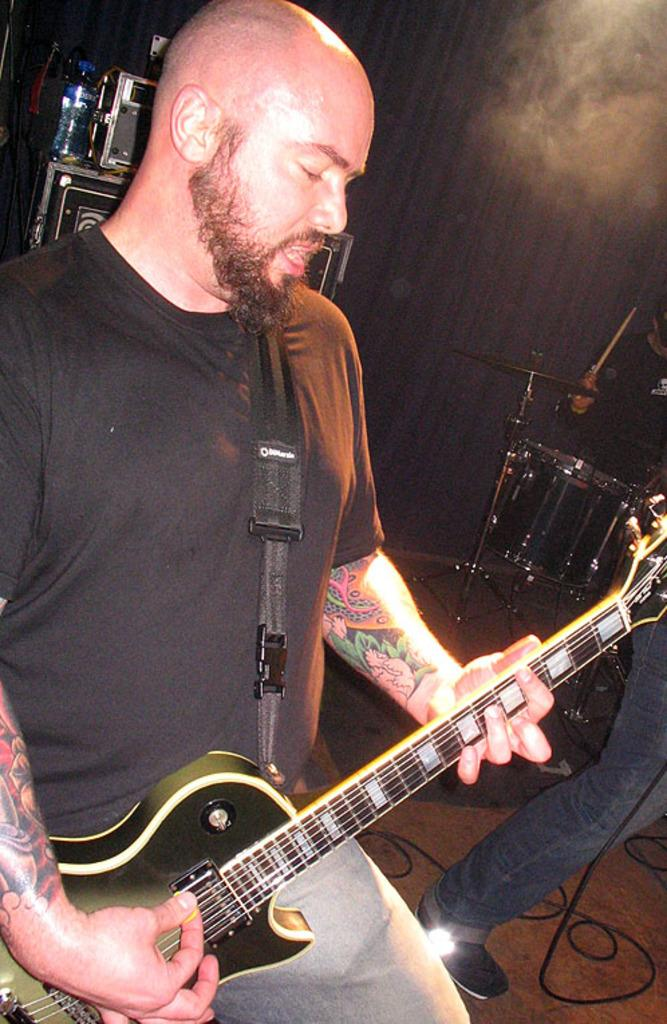What is the man in the image doing? The man is singing. What is the man wearing in the image? The man is wearing a black t-shirt. What instrument is the man holding in the image? The man is holding a guitar. What other musical instrument can be seen in the image? There are drums on the right side of the image. What type of locket is the man wearing around his neck in the image? There is no locket visible around the man's neck in the image. Can you see any mountains in the background of the image? There are no mountains present in the image. 